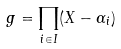<formula> <loc_0><loc_0><loc_500><loc_500>g = \prod _ { i \in I } ( X - \alpha _ { i } )</formula> 